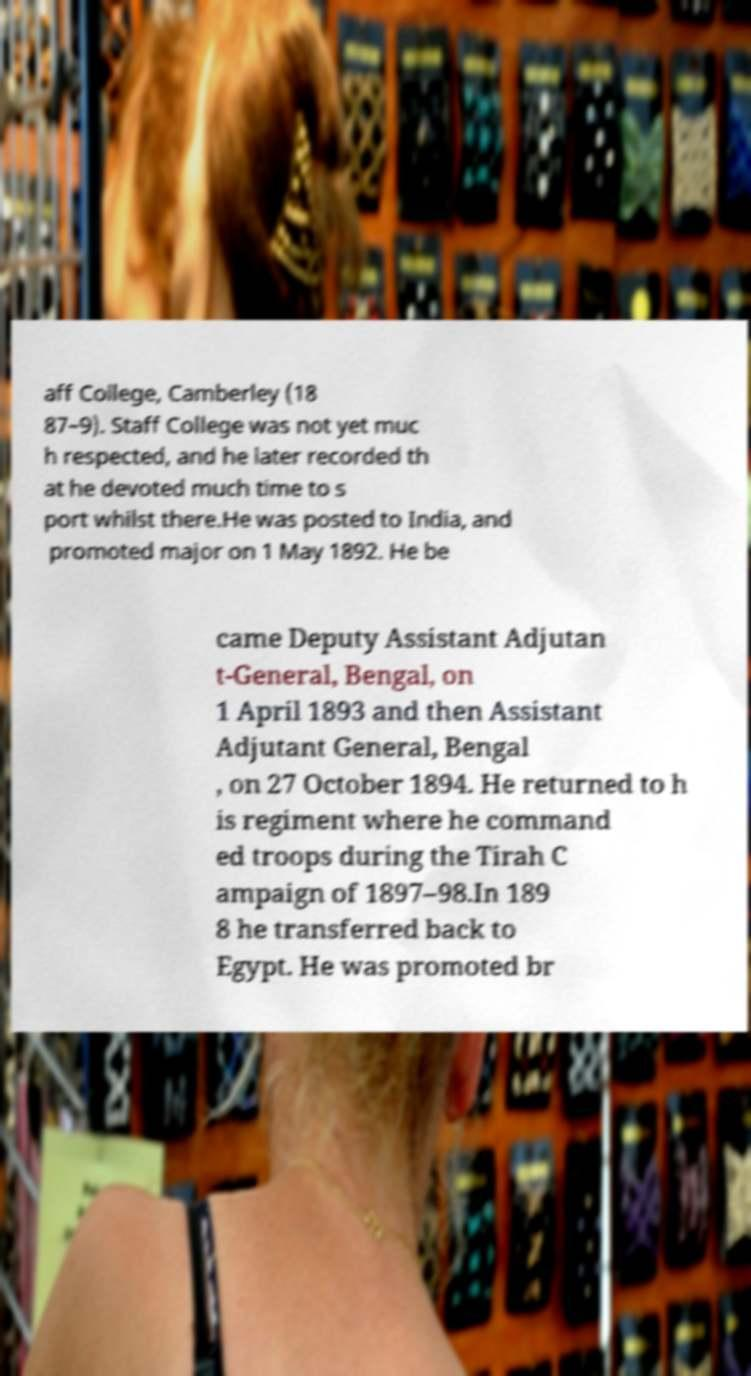What messages or text are displayed in this image? I need them in a readable, typed format. aff College, Camberley (18 87–9). Staff College was not yet muc h respected, and he later recorded th at he devoted much time to s port whilst there.He was posted to India, and promoted major on 1 May 1892. He be came Deputy Assistant Adjutan t-General, Bengal, on 1 April 1893 and then Assistant Adjutant General, Bengal , on 27 October 1894. He returned to h is regiment where he command ed troops during the Tirah C ampaign of 1897–98.In 189 8 he transferred back to Egypt. He was promoted br 